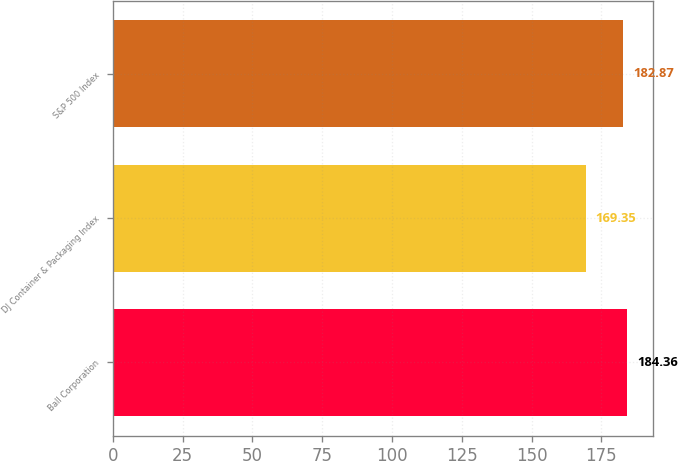Convert chart to OTSL. <chart><loc_0><loc_0><loc_500><loc_500><bar_chart><fcel>Ball Corporation<fcel>DJ Container & Packaging Index<fcel>S&P 500 Index<nl><fcel>184.36<fcel>169.35<fcel>182.87<nl></chart> 